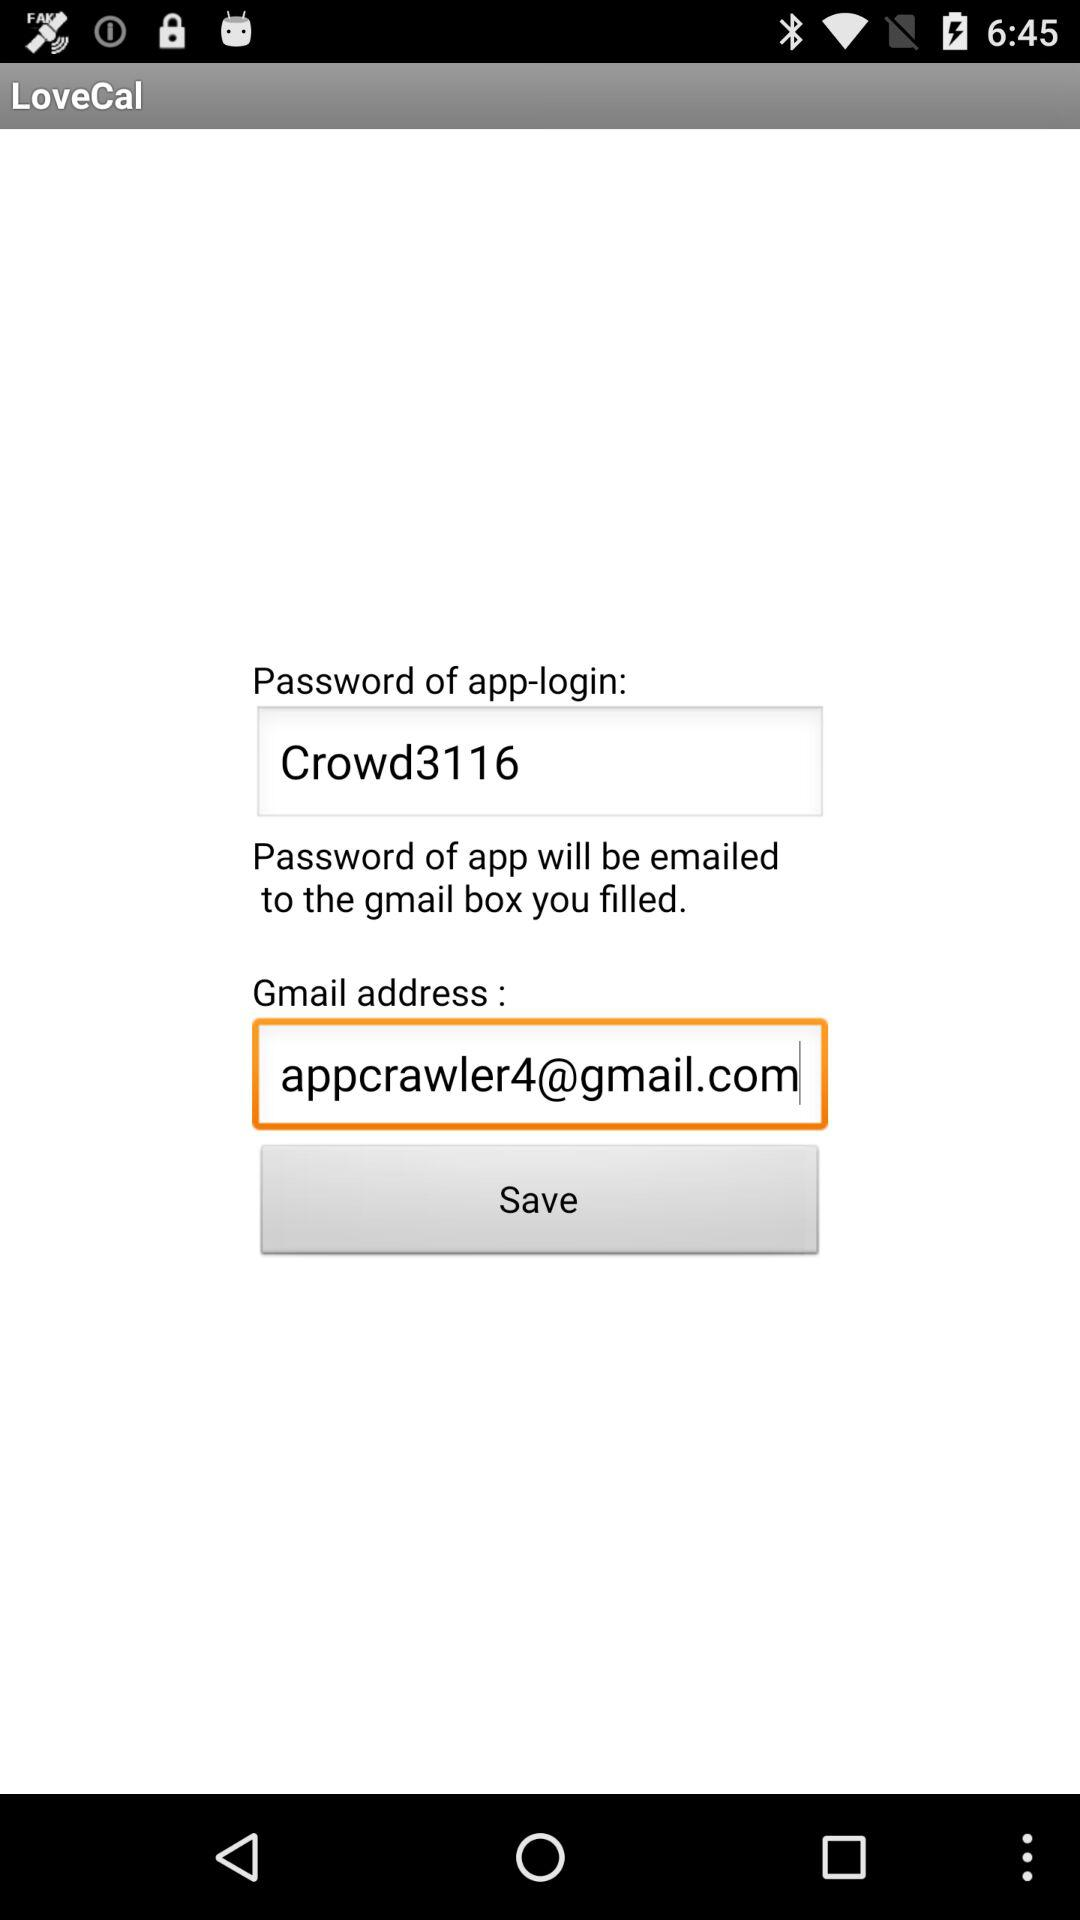How many text inputs are on the screen?
Answer the question using a single word or phrase. 2 